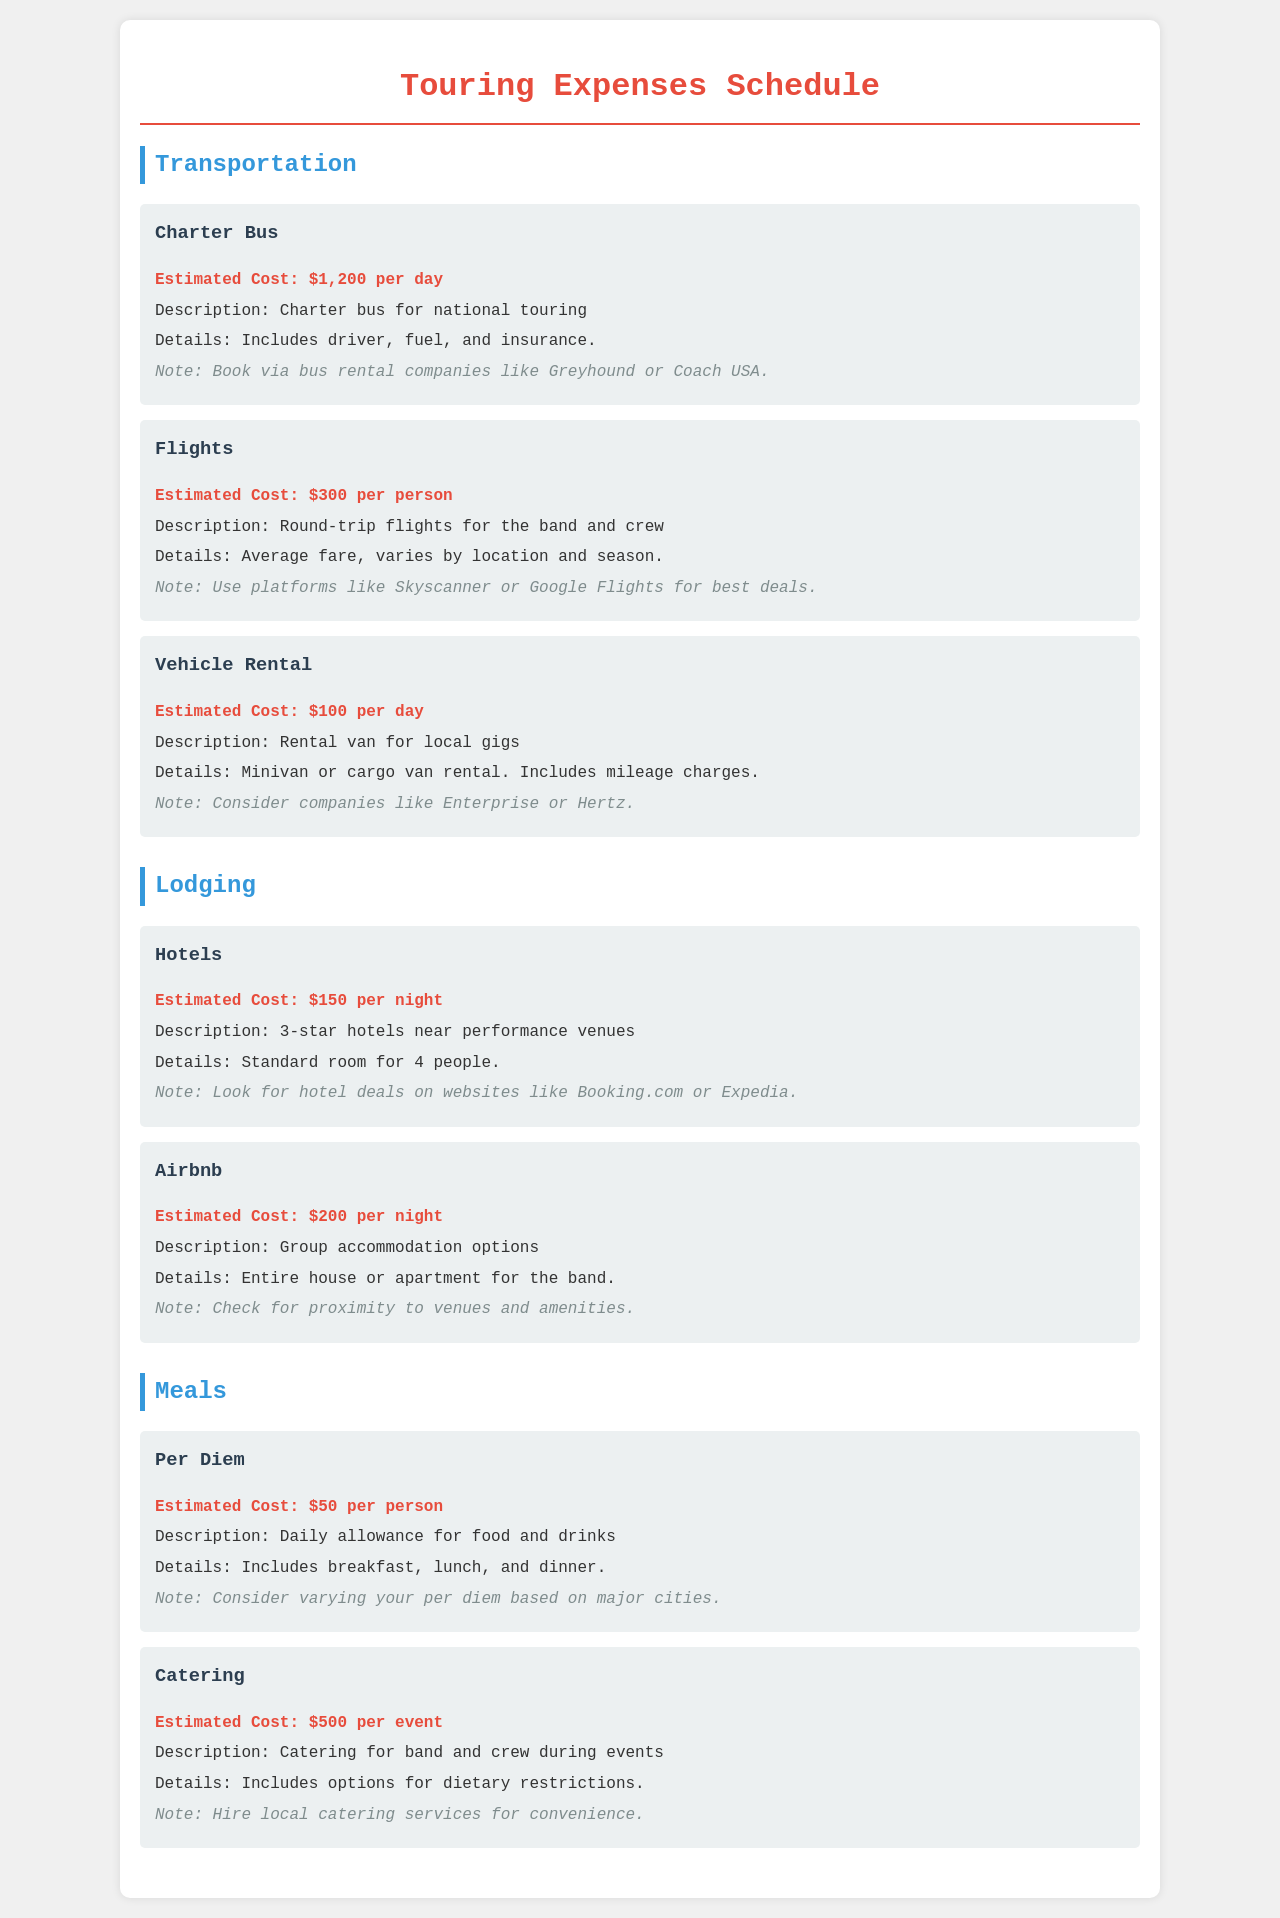What is the estimated cost of charter bus transportation? The estimated cost of charter bus transportation is listed as $1,200 per day in the document.
Answer: $1,200 per day How much does a round-trip flight cost per person? The document states that the estimated cost for a round-trip flight is $300 per person.
Answer: $300 per person What is the estimated cost for hotel lodging per night? According to the document, the estimated cost for hotel lodging is $150 per night.
Answer: $150 per night What is the estimated cost of catering per event? The document lists the estimated cost of catering as $500 per event.
Answer: $500 per event What is the per diem amount allocated for meals per person? The document indicates that the per diem amount for meals is estimated at $50 per person.
Answer: $50 per person Which transportation option includes a driver, fuel, and insurance? The charter bus is the transportation option that includes a driver, fuel, and insurance as per the document.
Answer: Charter Bus How does the estimated cost of Airbnb accommodation compare to hotel lodging? The document shows that Airbnb costs $200 per night, while hotel lodging costs $150 per night, making Airbnb more expensive.
Answer: $200 versus $150 What type of accommodation is described as a group option? The document describes Airbnb as a group accommodation option for the band.
Answer: Airbnb What should be checked for when hiring local catering services? According to the document, dietary restrictions should be considered when hiring local catering services.
Answer: Dietary restrictions 